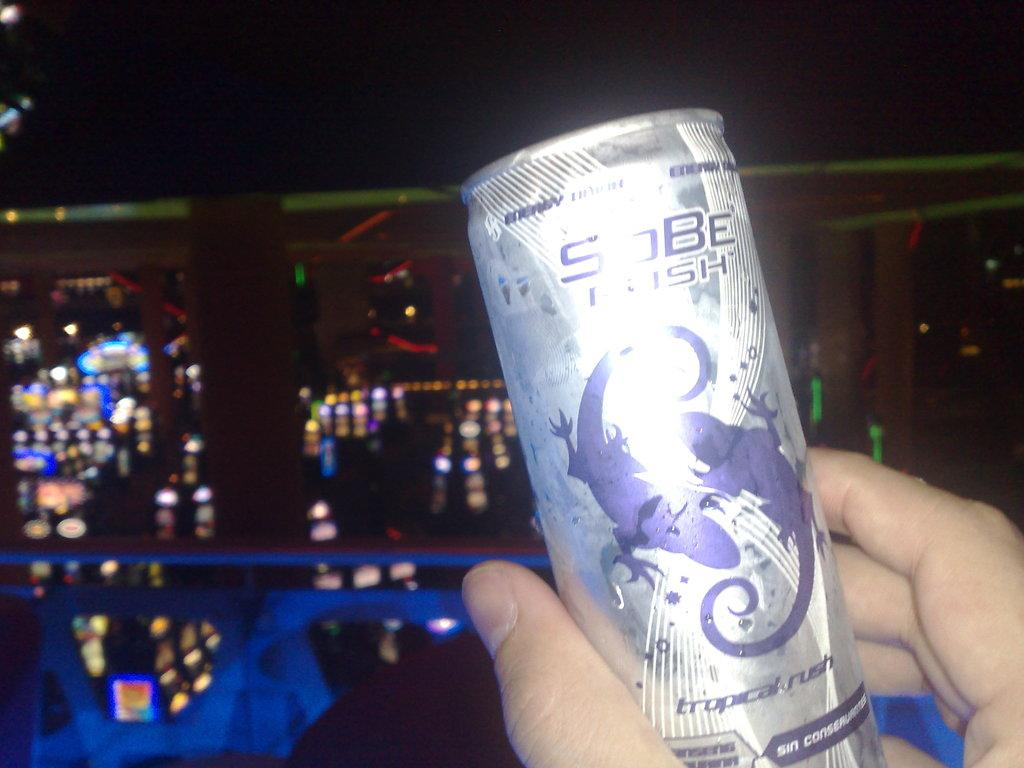<image>
Give a short and clear explanation of the subsequent image. Someone is holding up a can that says "tropical rush" on it. 